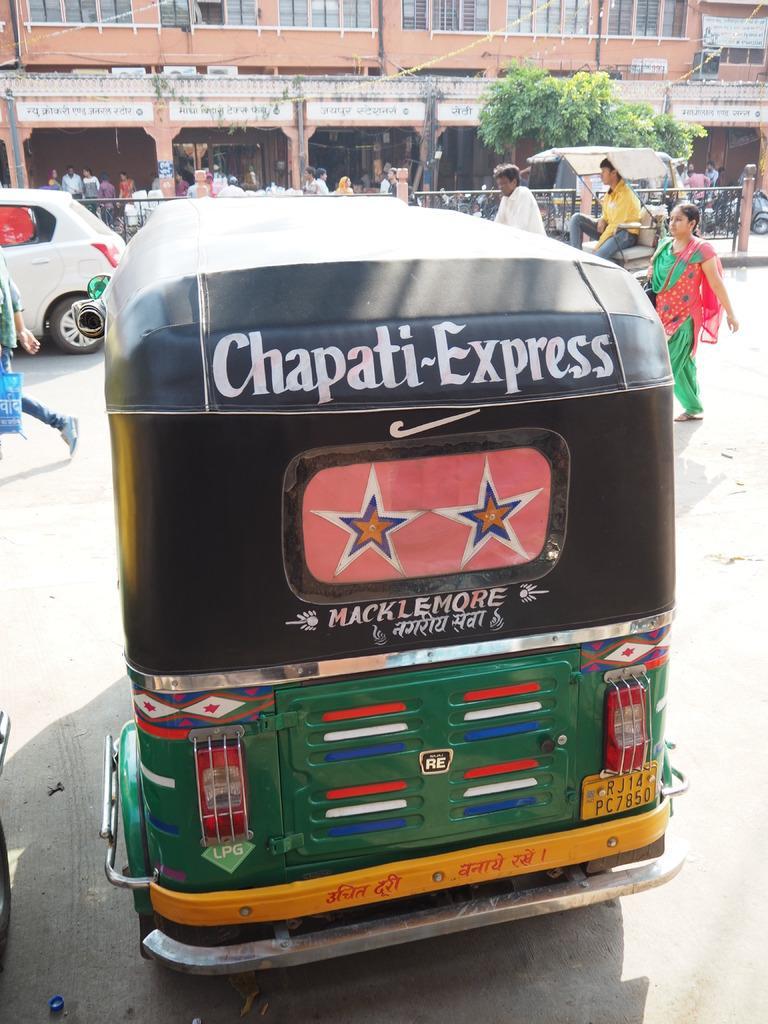Could you give a brief overview of what you see in this image? There is a auto in the middle of this image and there are some persons in the background. We can see there is a car on the left side of this image, and there is a tree on the right side of this image. There is a building at the top of this image. 